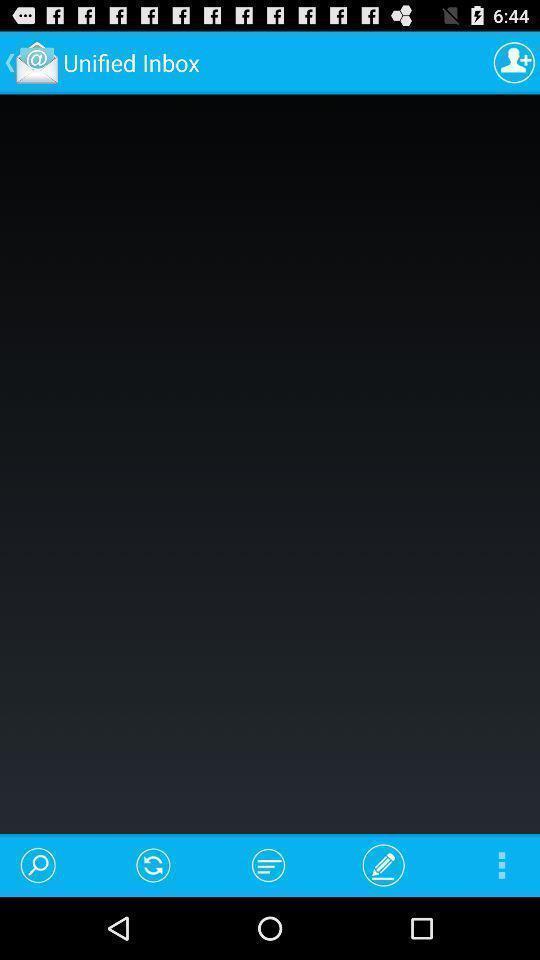Explain the elements present in this screenshot. Page showing information about application. 